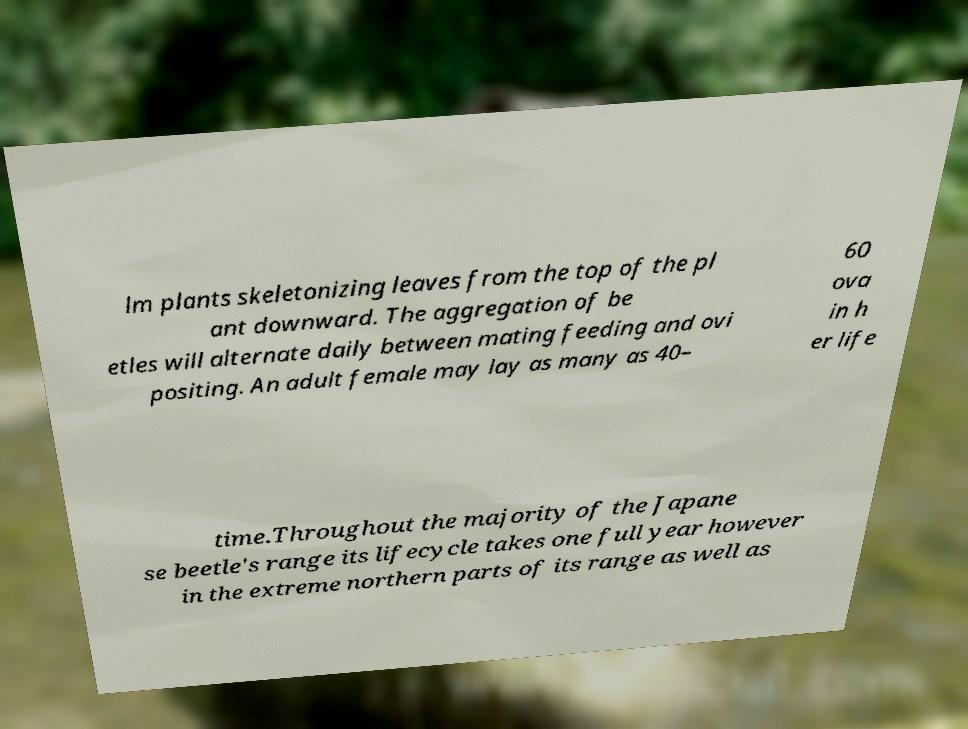For documentation purposes, I need the text within this image transcribed. Could you provide that? lm plants skeletonizing leaves from the top of the pl ant downward. The aggregation of be etles will alternate daily between mating feeding and ovi positing. An adult female may lay as many as 40– 60 ova in h er life time.Throughout the majority of the Japane se beetle's range its lifecycle takes one full year however in the extreme northern parts of its range as well as 